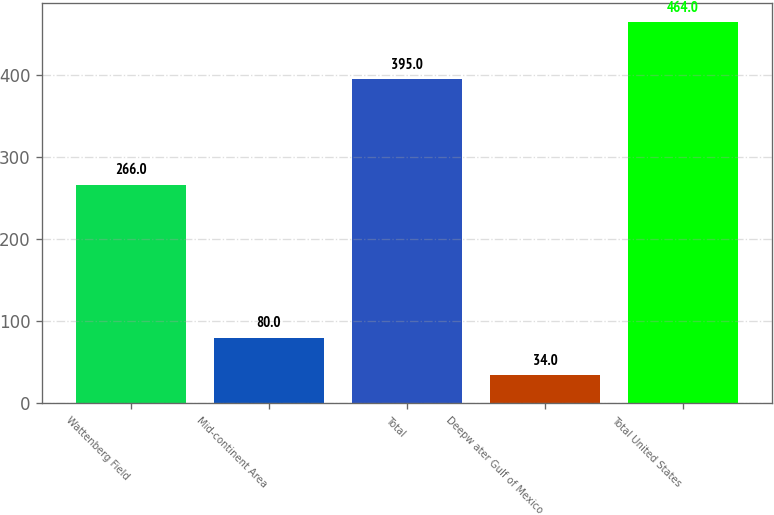Convert chart. <chart><loc_0><loc_0><loc_500><loc_500><bar_chart><fcel>Wattenberg Field<fcel>Mid-continent Area<fcel>Total<fcel>Deepw ater Gulf of Mexico<fcel>Total United States<nl><fcel>266<fcel>80<fcel>395<fcel>34<fcel>464<nl></chart> 